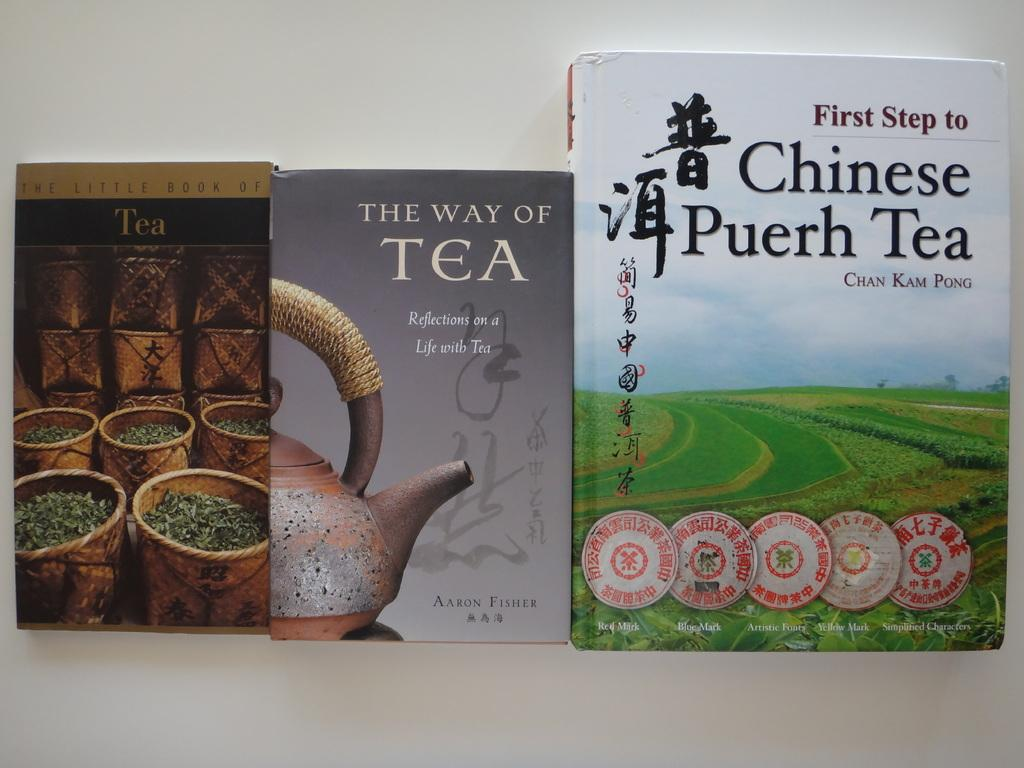<image>
Share a concise interpretation of the image provided. three books about tea, the little book of tea, the way of tea, and first step to chinese puerh tea 